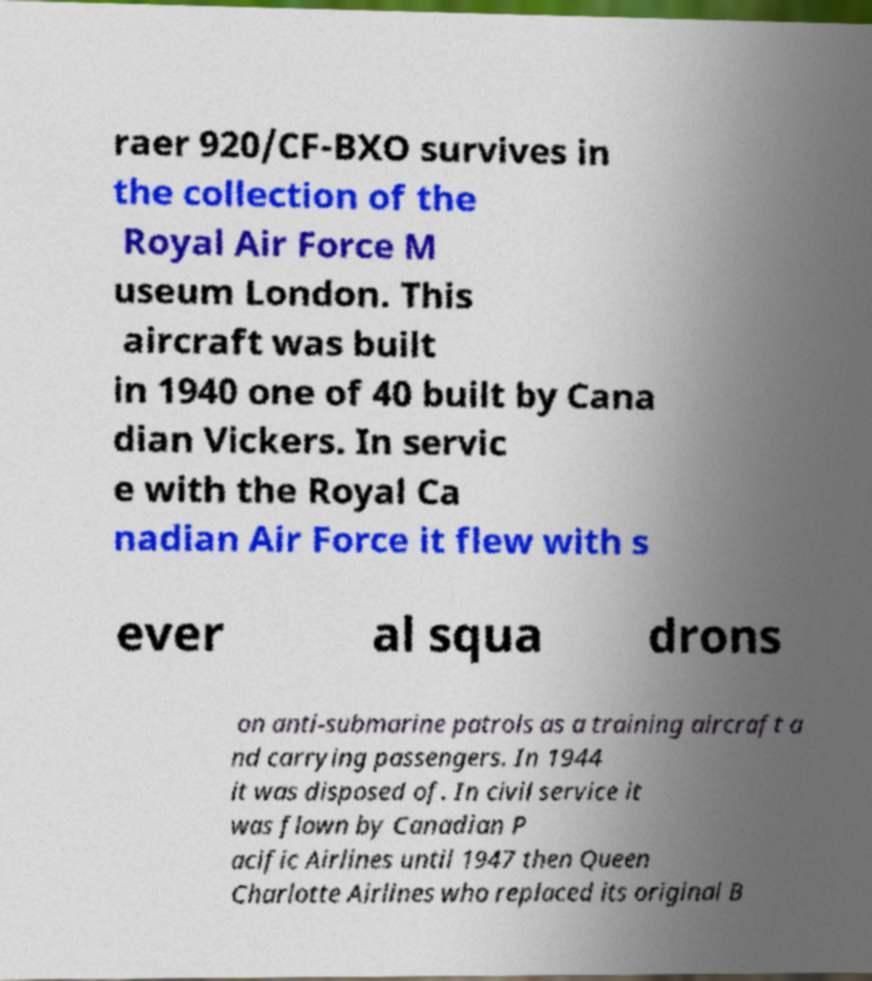Could you extract and type out the text from this image? raer 920/CF-BXO survives in the collection of the Royal Air Force M useum London. This aircraft was built in 1940 one of 40 built by Cana dian Vickers. In servic e with the Royal Ca nadian Air Force it flew with s ever al squa drons on anti-submarine patrols as a training aircraft a nd carrying passengers. In 1944 it was disposed of. In civil service it was flown by Canadian P acific Airlines until 1947 then Queen Charlotte Airlines who replaced its original B 